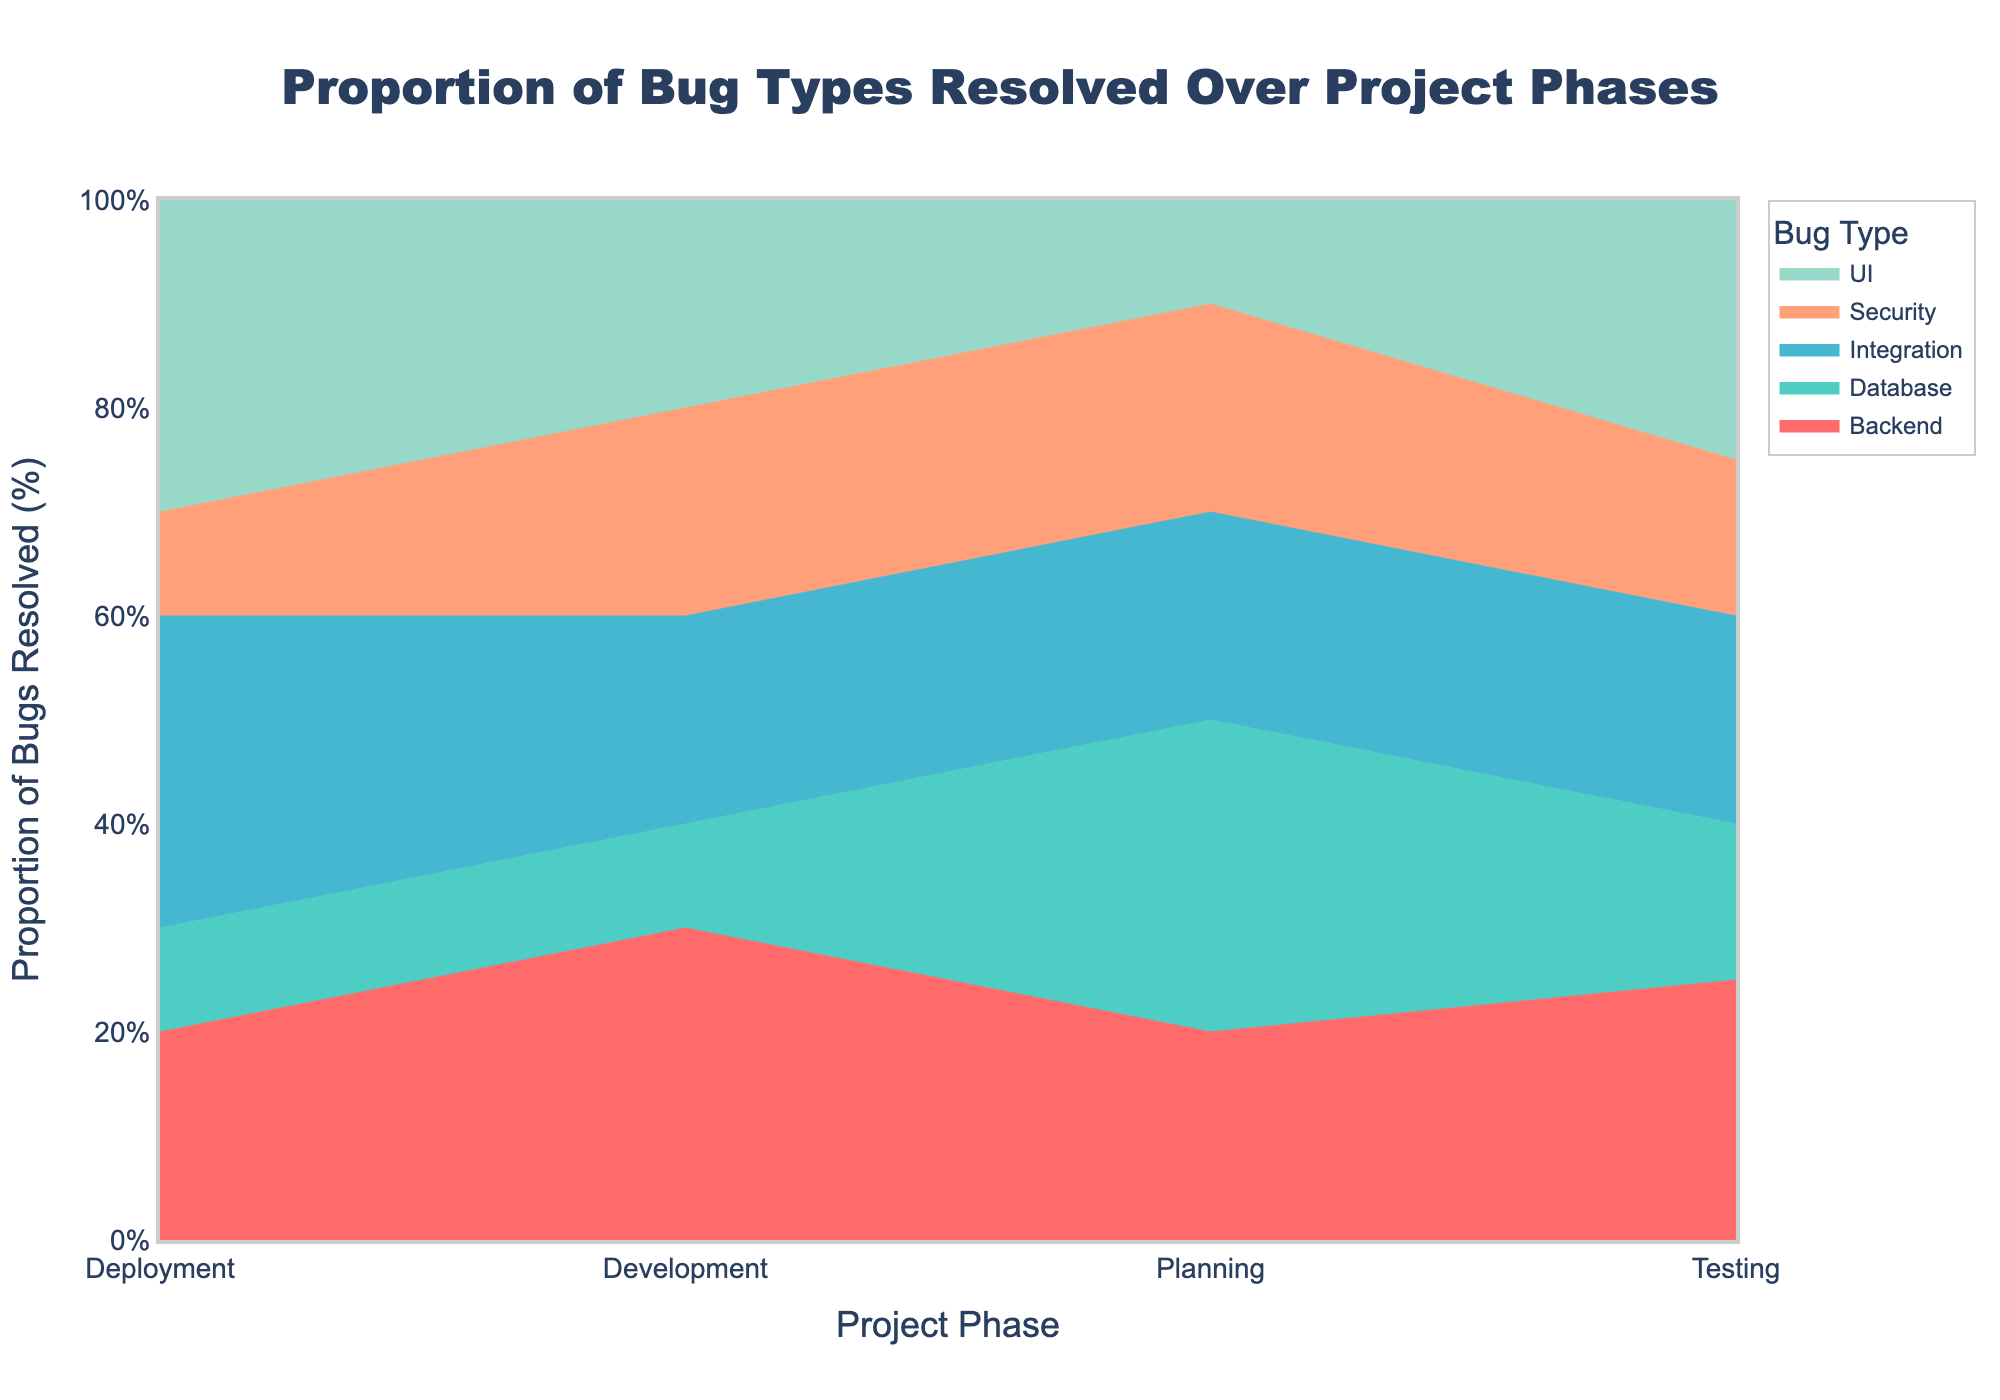What are the different project phases represented in the figure? The x-axis of the chart shows the different project phases. From the figure, the phases are Planning, Development, Testing, and Deployment.
Answer: Planning, Development, Testing, Deployment Which bug type shows the highest proportion resolved during the Planning phase? In the Planning phase, the color corresponding to the highest vertical segment represents the bug type resolved most. The highest segment is Database, showing the highest proportion of 0.3 or 30%.
Answer: Database How much higher is the proportion of UI bugs resolved in the Deployment phase compared to the Testing phase? The Deployment phase shows 30% for UI bugs, while the Testing phase shows 25% for UI bugs. The difference is 30% - 25% = 5%.
Answer: 5% What is the total proportion of non-security bugs resolved in the Development phase? To find the total, sum the proportions of UI, Backend, Database, and Integration bugs resolved in Development. That's 20% + 30% + 10% + 20% = 80%.
Answer: 80% Which project phase shows the lowest proportion of security bugs resolved? By comparison across phases, the Deployment phase shows the lowest proportion for Security bugs, which is 10%.
Answer: Deployment How does the proportion of backend bugs resolved change from Planning to Deployment? Observing the chart, Backend bugs proportion is 20% in Planning, increases to 30% in Development, remains at 25% in Testing, and decreases to 20% in Deployment.
Answer: Increases, then decreases Which phase shows an equal proportion of resolved UI and Integration bugs? The Development phase shows an equal proportion of UI and Integration bugs resolved, both at 20%.
Answer: Development What is the combined proportion of Database and Integration bugs resolved in the Testing phase? In Testing, the Database bugs proportion is 15% and Integration bugs proportion is 20%. Combined, it's 15% + 20% = 35%.
Answer: 35% Which bug type shows the most consistent proportion resolved across all phases? By observing the chart, Security and Integration bug types appear consistent. Security shows 20%, 20%, 15%, and 10%, while Integration shows 20%, 20%, 20%, and 30%. Security varies more, so Integration is most consistent.
Answer: Integration What trend is observed in UI bug resolution proportion across the project phases? The trend in UI bugs resolution starts at 10% in Planning, increases to 20% in Development, rises further to 25% in Testing, and peaks at 30% in Deployment.
Answer: Increasing trend 